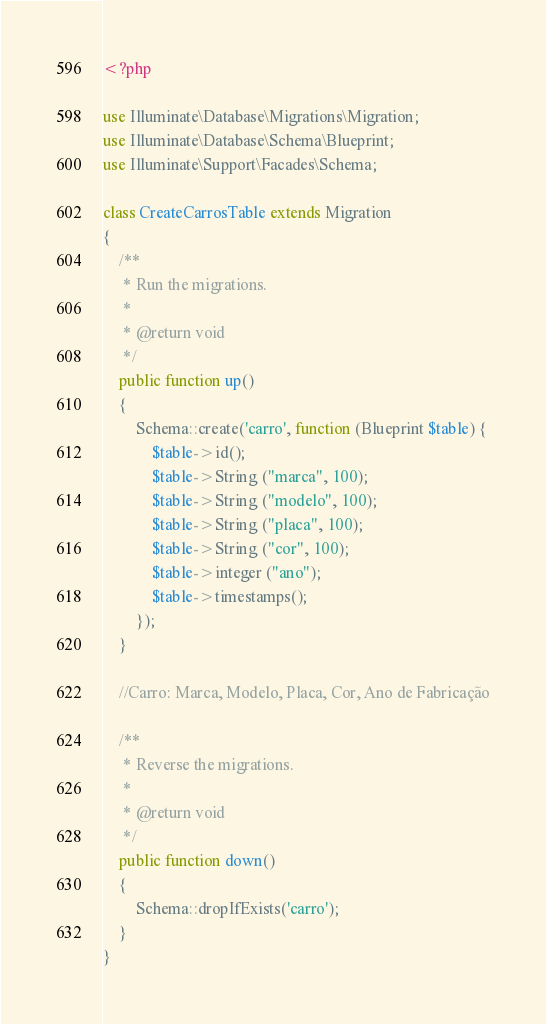Convert code to text. <code><loc_0><loc_0><loc_500><loc_500><_PHP_><?php

use Illuminate\Database\Migrations\Migration;
use Illuminate\Database\Schema\Blueprint;
use Illuminate\Support\Facades\Schema;

class CreateCarrosTable extends Migration
{
    /**
     * Run the migrations.
     *
     * @return void
     */
    public function up()
    {
        Schema::create('carro', function (Blueprint $table) {
            $table->id();
			$table->String ("marca", 100);
			$table->String ("modelo", 100);
			$table->String ("placa", 100);
			$table->String ("cor", 100);
			$table->integer ("ano");
            $table->timestamps();
        });
    }
	
	//Carro: Marca, Modelo, Placa, Cor, Ano de Fabricação

    /**
     * Reverse the migrations.
     *
     * @return void
     */
    public function down()
    {
        Schema::dropIfExists('carro');
    }
}
</code> 